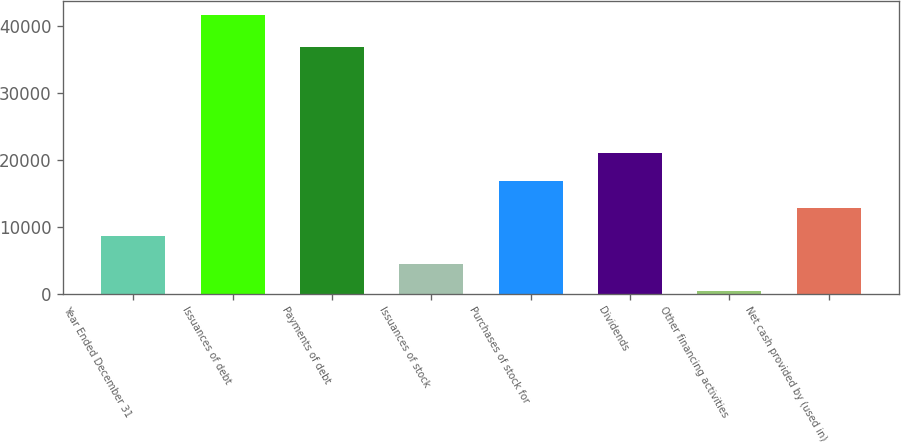<chart> <loc_0><loc_0><loc_500><loc_500><bar_chart><fcel>Year Ended December 31<fcel>Issuances of debt<fcel>Payments of debt<fcel>Issuances of stock<fcel>Purchases of stock for<fcel>Dividends<fcel>Other financing activities<fcel>Net cash provided by (used in)<nl><fcel>8625.2<fcel>41674<fcel>36962<fcel>4494.1<fcel>16887.4<fcel>21018.5<fcel>363<fcel>12756.3<nl></chart> 